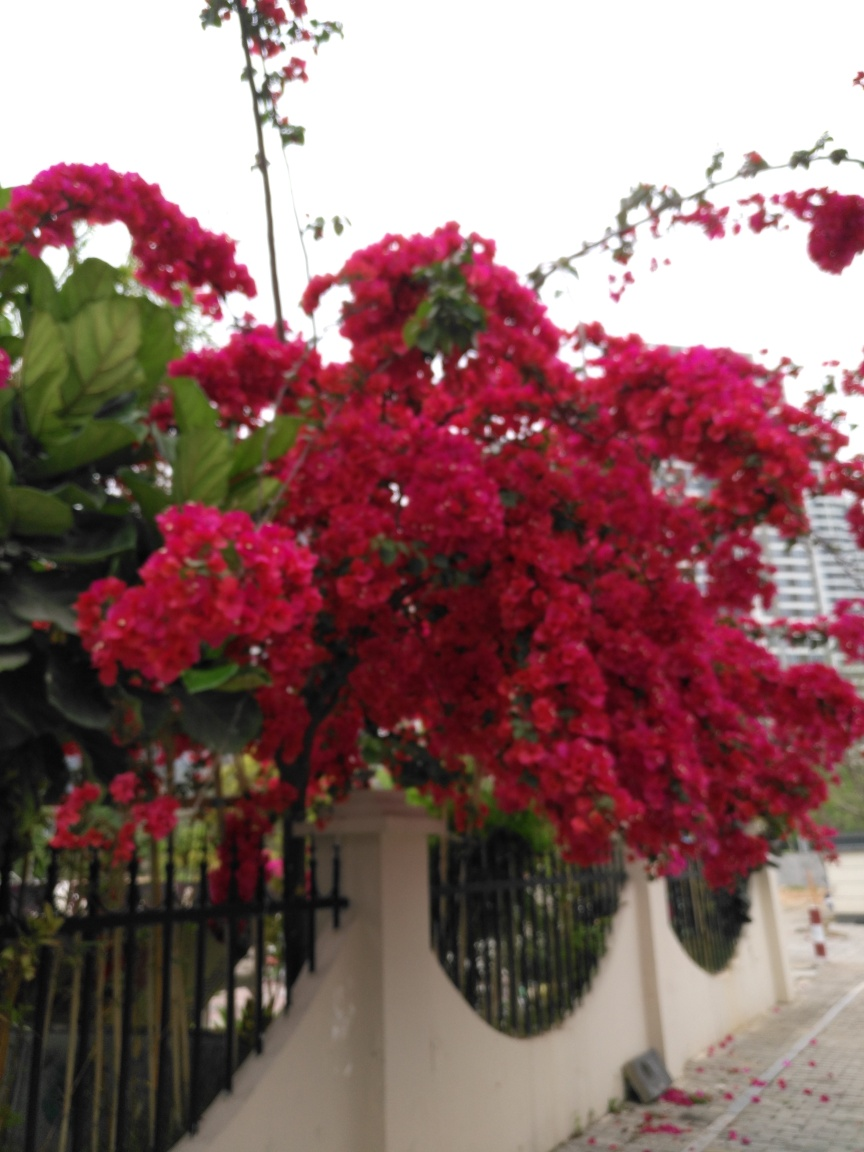What time of day does the lighting suggest it is? The diffused natural lighting in the image suggests it could be either morning or late afternoon, a time when the sunlight is not as harsh, giving the scene a gentler ambience. 